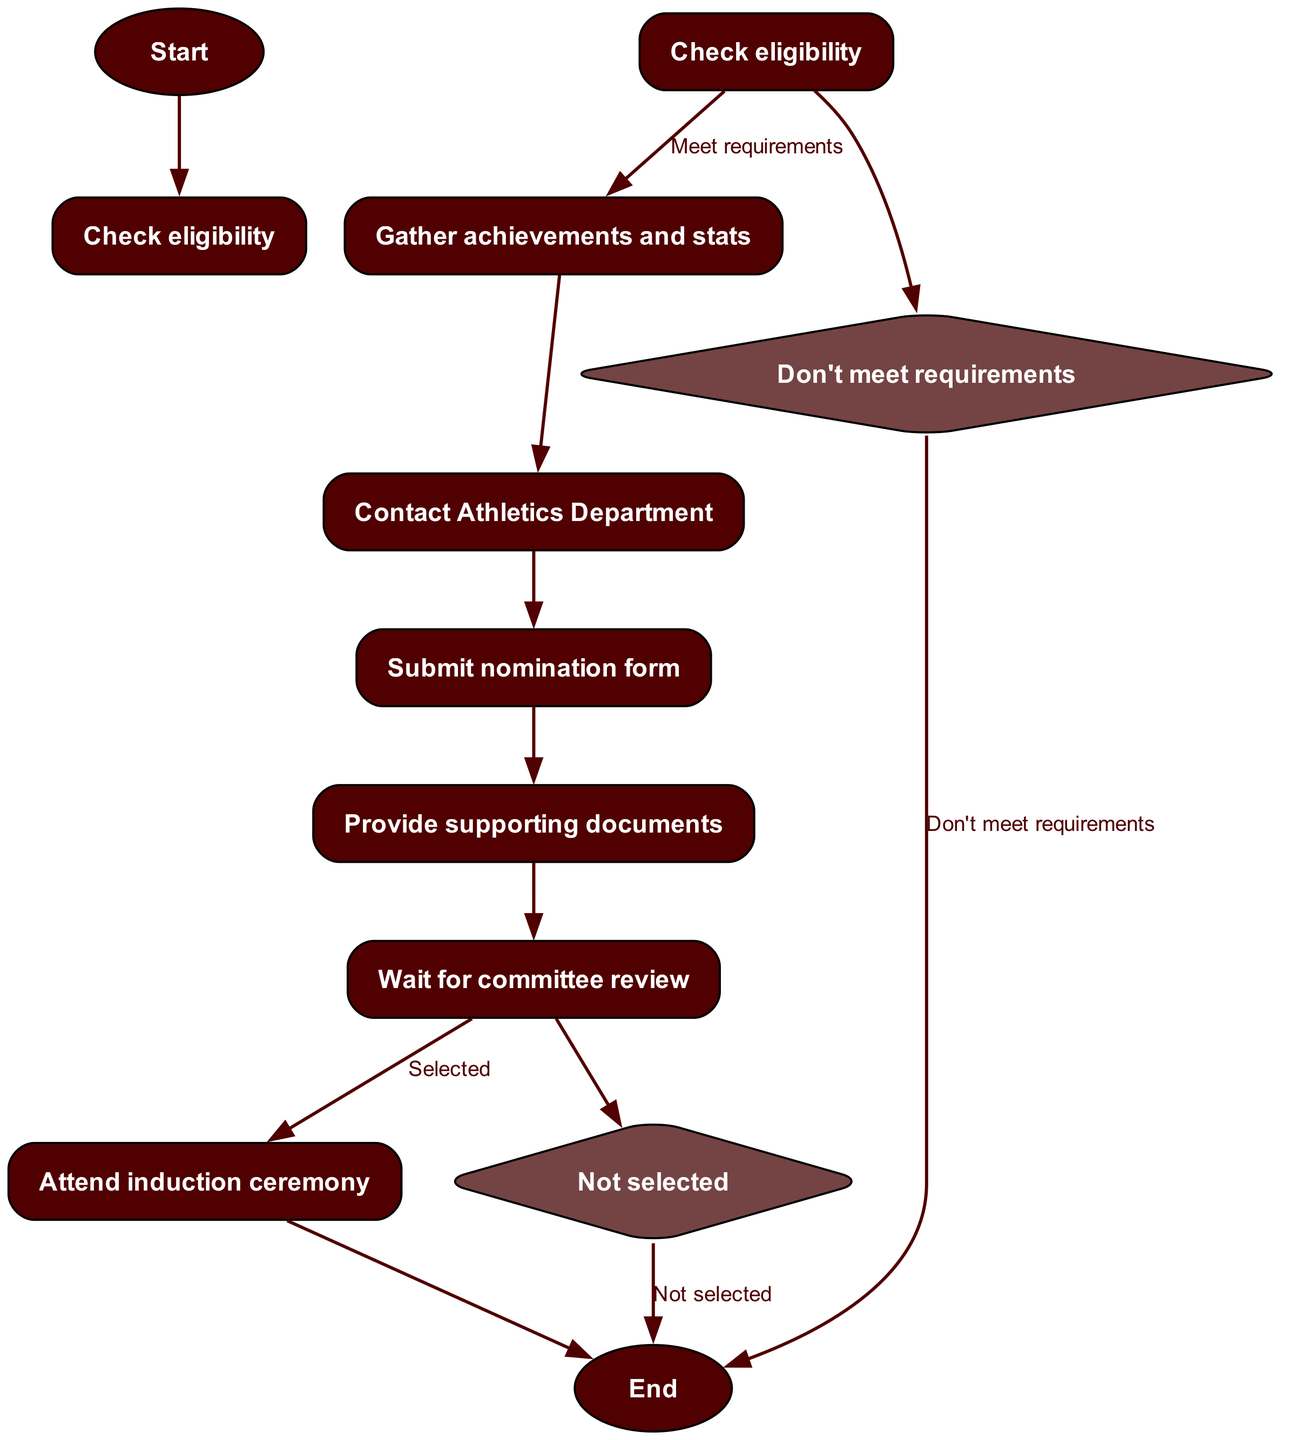What is the first step in the nomination process? The diagram starts at "Check eligibility" as the first step in the nomination process.
Answer: Check eligibility How many options are available after checking eligibility? After "Check eligibility," there are two options: "Meet requirements" and "Don't meet requirements." Therefore, there are two options.
Answer: 2 What happens if the eligibility requirements are not met? If the eligibility requirements are not met, the process ends, leading directly to "End."
Answer: End What is required after gathering achievements and stats? After "Gather achievements and stats," the next step is to "Contact Athletics Department."
Answer: Contact Athletics Department What step follows the submission of the nomination form? The step that follows "Submit nomination form" is "Provide supporting documents."
Answer: Provide supporting documents What decision is made after the committee review? After the "Wait for committee review," a decision is made: either "Selected" or "Not selected."
Answer: Selected or Not selected What occurs if a nominee is selected? If a nominee is selected, they will "Attend induction ceremony," which is the next step after selection.
Answer: Attend induction ceremony How many total steps are there in the application process, including start and end nodes? The total number of steps, including both start and end nodes, is 8: "Start," 6 process steps, and "End."
Answer: 8 What type of node represents a decision point in the diagram? The decision points in the diagram are represented by diamond-shaped nodes, specifically for options like "Don't meet requirements" and "Selected."
Answer: Diamond-shaped nodes 